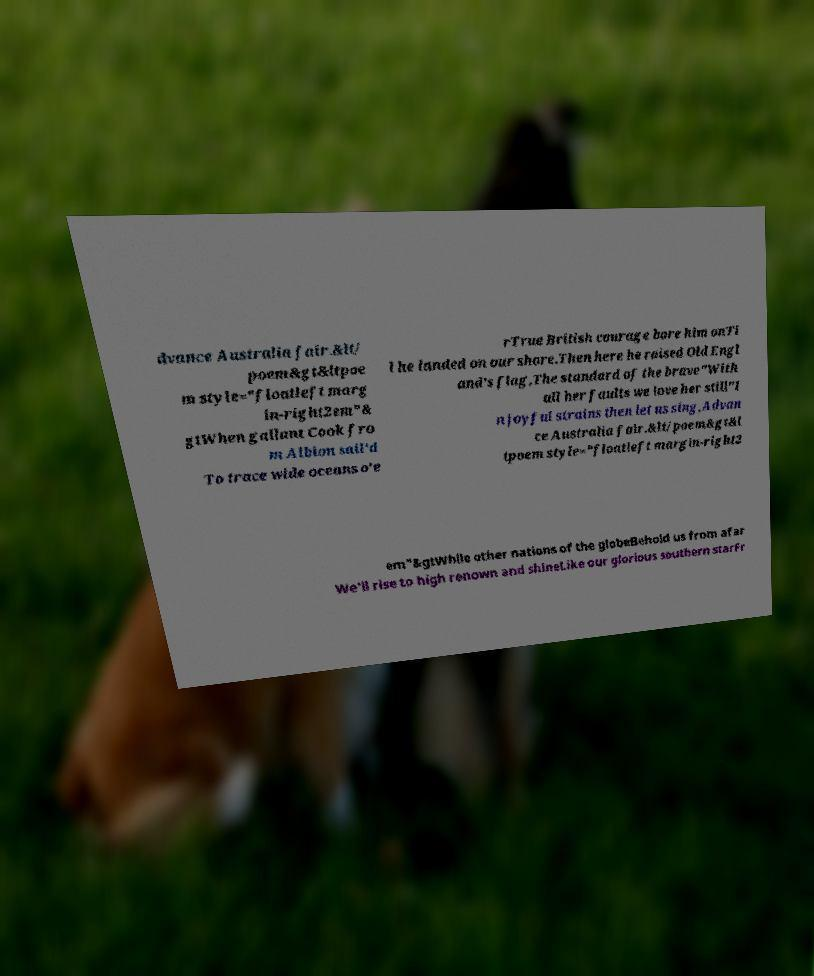Please read and relay the text visible in this image. What does it say? dvance Australia fair.&lt/ poem&gt&ltpoe m style="floatleft marg in-right2em"& gtWhen gallant Cook fro m Albion sail'd To trace wide oceans o'e rTrue British courage bore him onTi l he landed on our shore.Then here he raised Old Engl and's flag,The standard of the brave"With all her faults we love her still"I n joyful strains then let us sing,Advan ce Australia fair.&lt/poem&gt&l tpoem style="floatleft margin-right2 em"&gtWhile other nations of the globeBehold us from afar We'll rise to high renown and shineLike our glorious southern starFr 